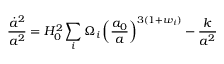<formula> <loc_0><loc_0><loc_500><loc_500>\frac { \dot { a } ^ { 2 } } { a ^ { 2 } } = H _ { 0 } ^ { 2 } \sum _ { i } \Omega _ { i } \left ( \frac { a _ { 0 } } { a } \right ) ^ { 3 ( 1 + w _ { i } ) } - \frac { k } { a ^ { 2 } }</formula> 